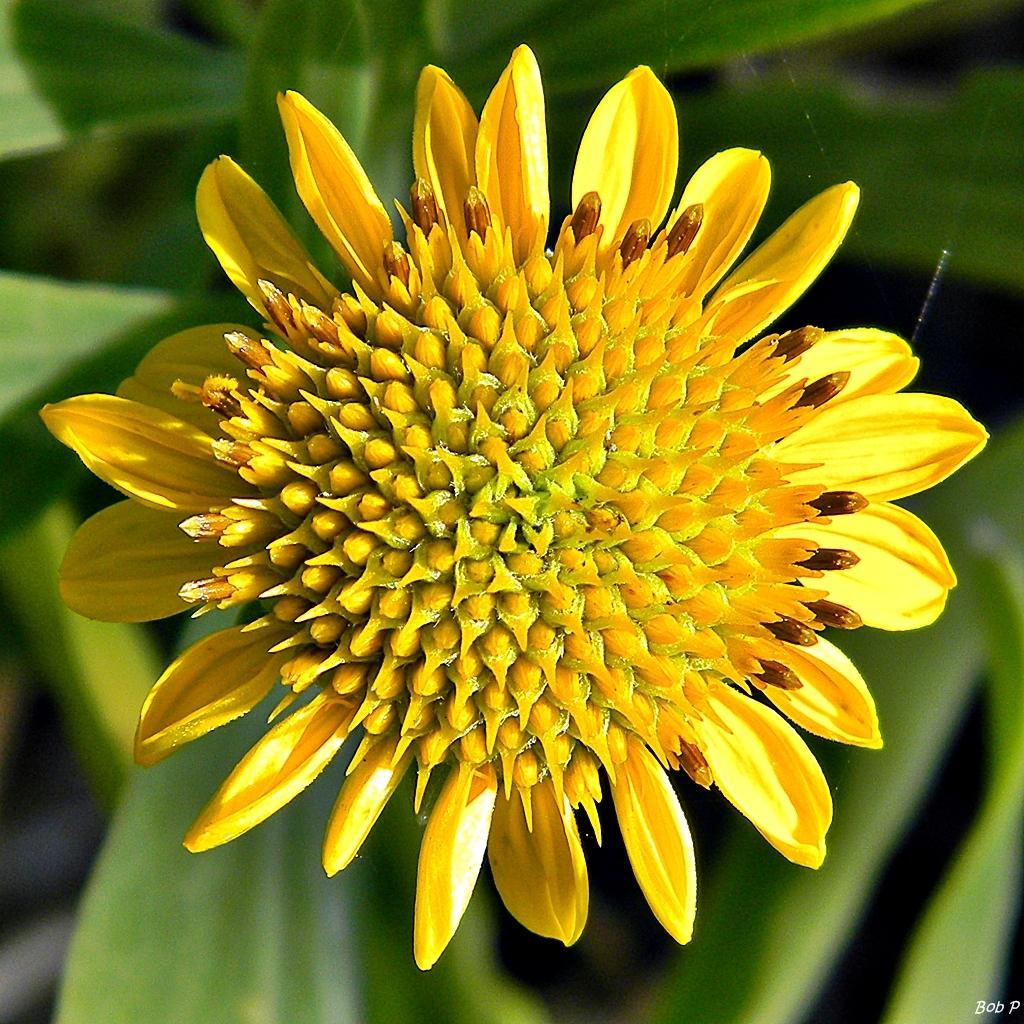Describe this image in one or two sentences. In the image we can see a flower, yellow in color and these are the leaves. 